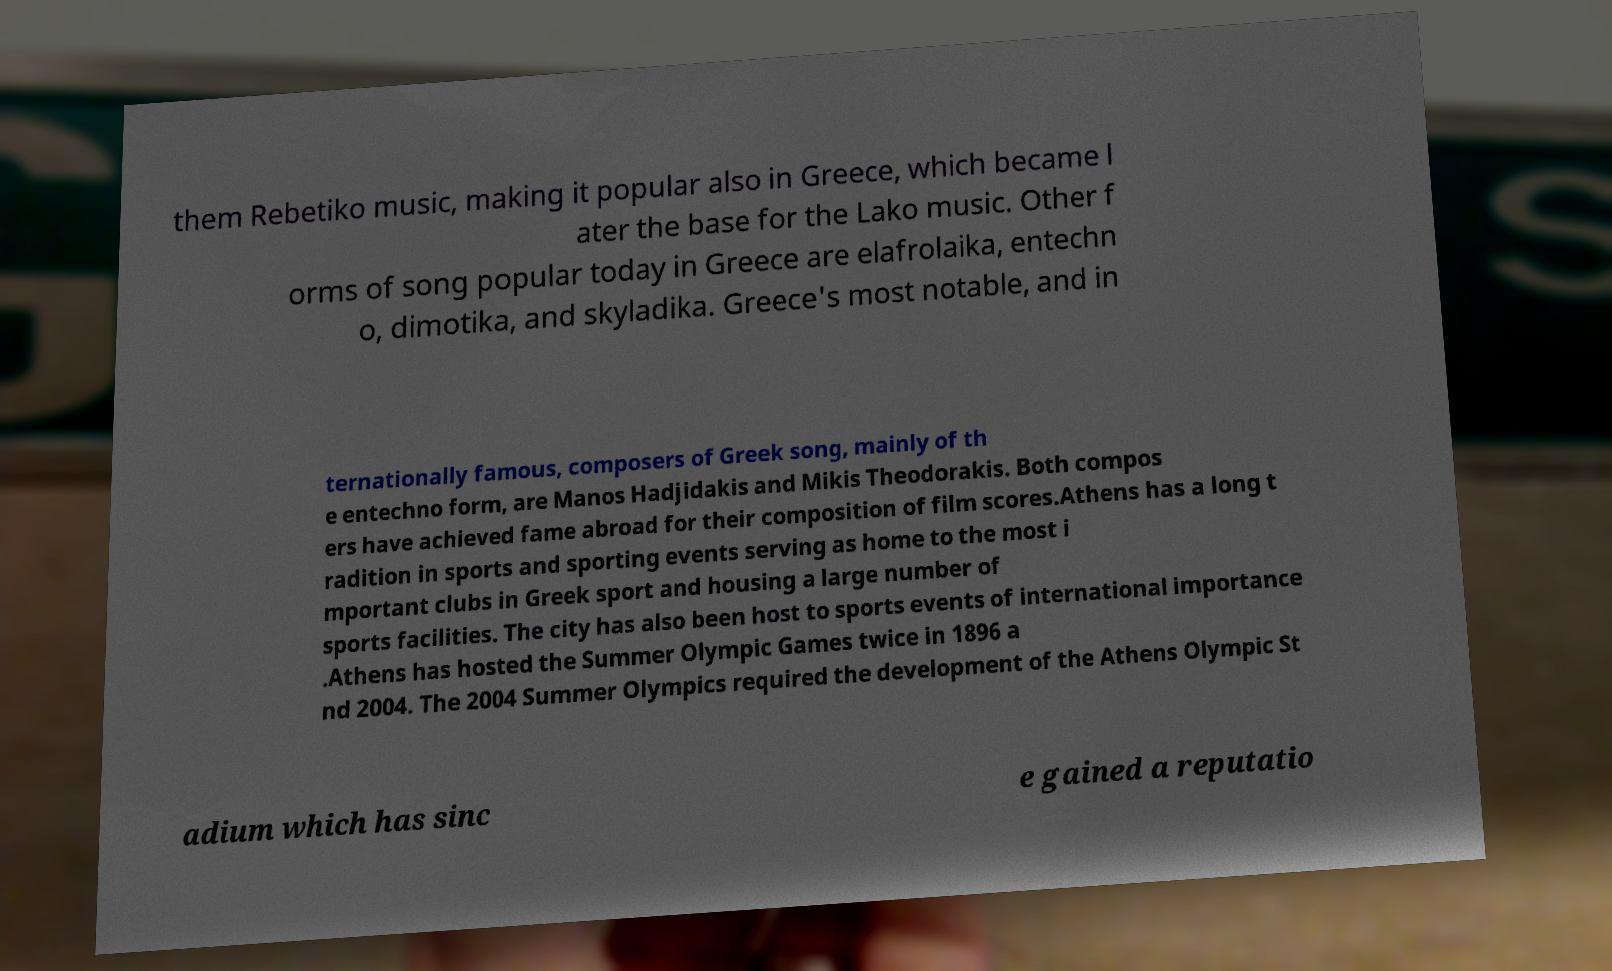Could you extract and type out the text from this image? them Rebetiko music, making it popular also in Greece, which became l ater the base for the Lako music. Other f orms of song popular today in Greece are elafrolaika, entechn o, dimotika, and skyladika. Greece's most notable, and in ternationally famous, composers of Greek song, mainly of th e entechno form, are Manos Hadjidakis and Mikis Theodorakis. Both compos ers have achieved fame abroad for their composition of film scores.Athens has a long t radition in sports and sporting events serving as home to the most i mportant clubs in Greek sport and housing a large number of sports facilities. The city has also been host to sports events of international importance .Athens has hosted the Summer Olympic Games twice in 1896 a nd 2004. The 2004 Summer Olympics required the development of the Athens Olympic St adium which has sinc e gained a reputatio 